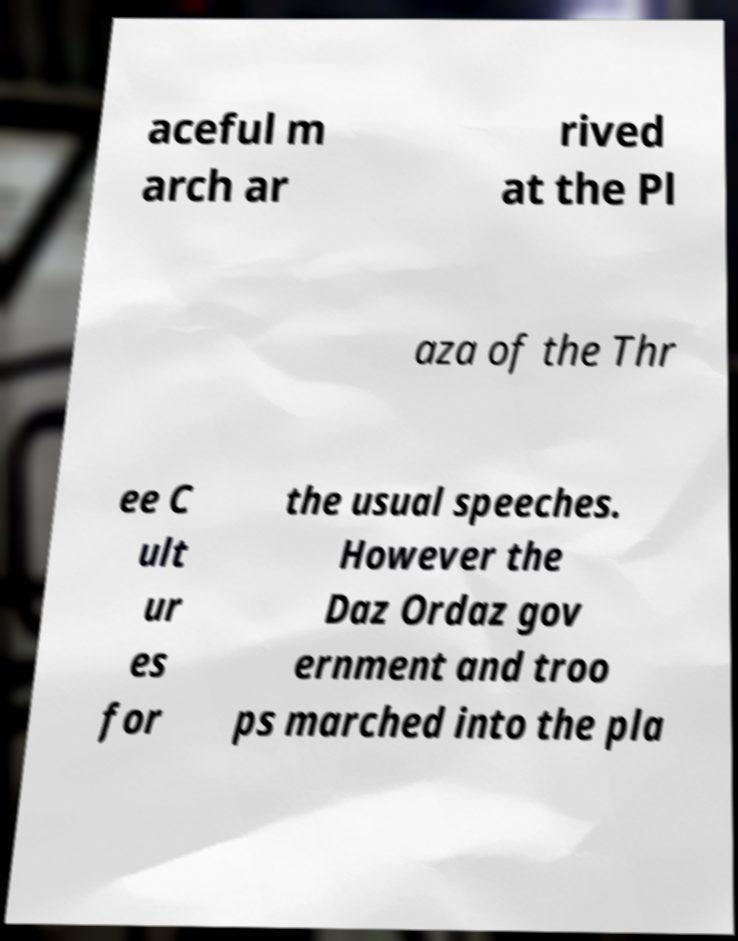Can you read and provide the text displayed in the image?This photo seems to have some interesting text. Can you extract and type it out for me? aceful m arch ar rived at the Pl aza of the Thr ee C ult ur es for the usual speeches. However the Daz Ordaz gov ernment and troo ps marched into the pla 